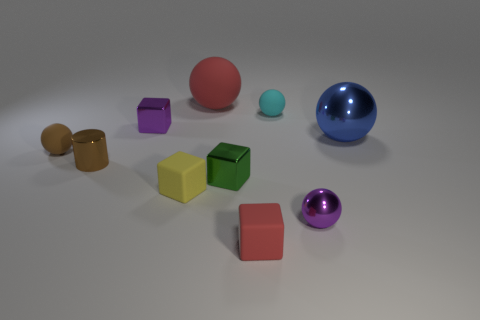Subtract all yellow rubber blocks. How many blocks are left? 3 Subtract all blue spheres. How many spheres are left? 4 Subtract all cylinders. How many objects are left? 9 Subtract all gray spheres. Subtract all green cubes. How many spheres are left? 5 Subtract all red cubes. How many purple balls are left? 1 Subtract all green metallic blocks. Subtract all tiny cyan shiny cubes. How many objects are left? 9 Add 7 purple metal blocks. How many purple metal blocks are left? 8 Add 2 tiny purple spheres. How many tiny purple spheres exist? 3 Subtract 1 purple cubes. How many objects are left? 9 Subtract 1 cubes. How many cubes are left? 3 